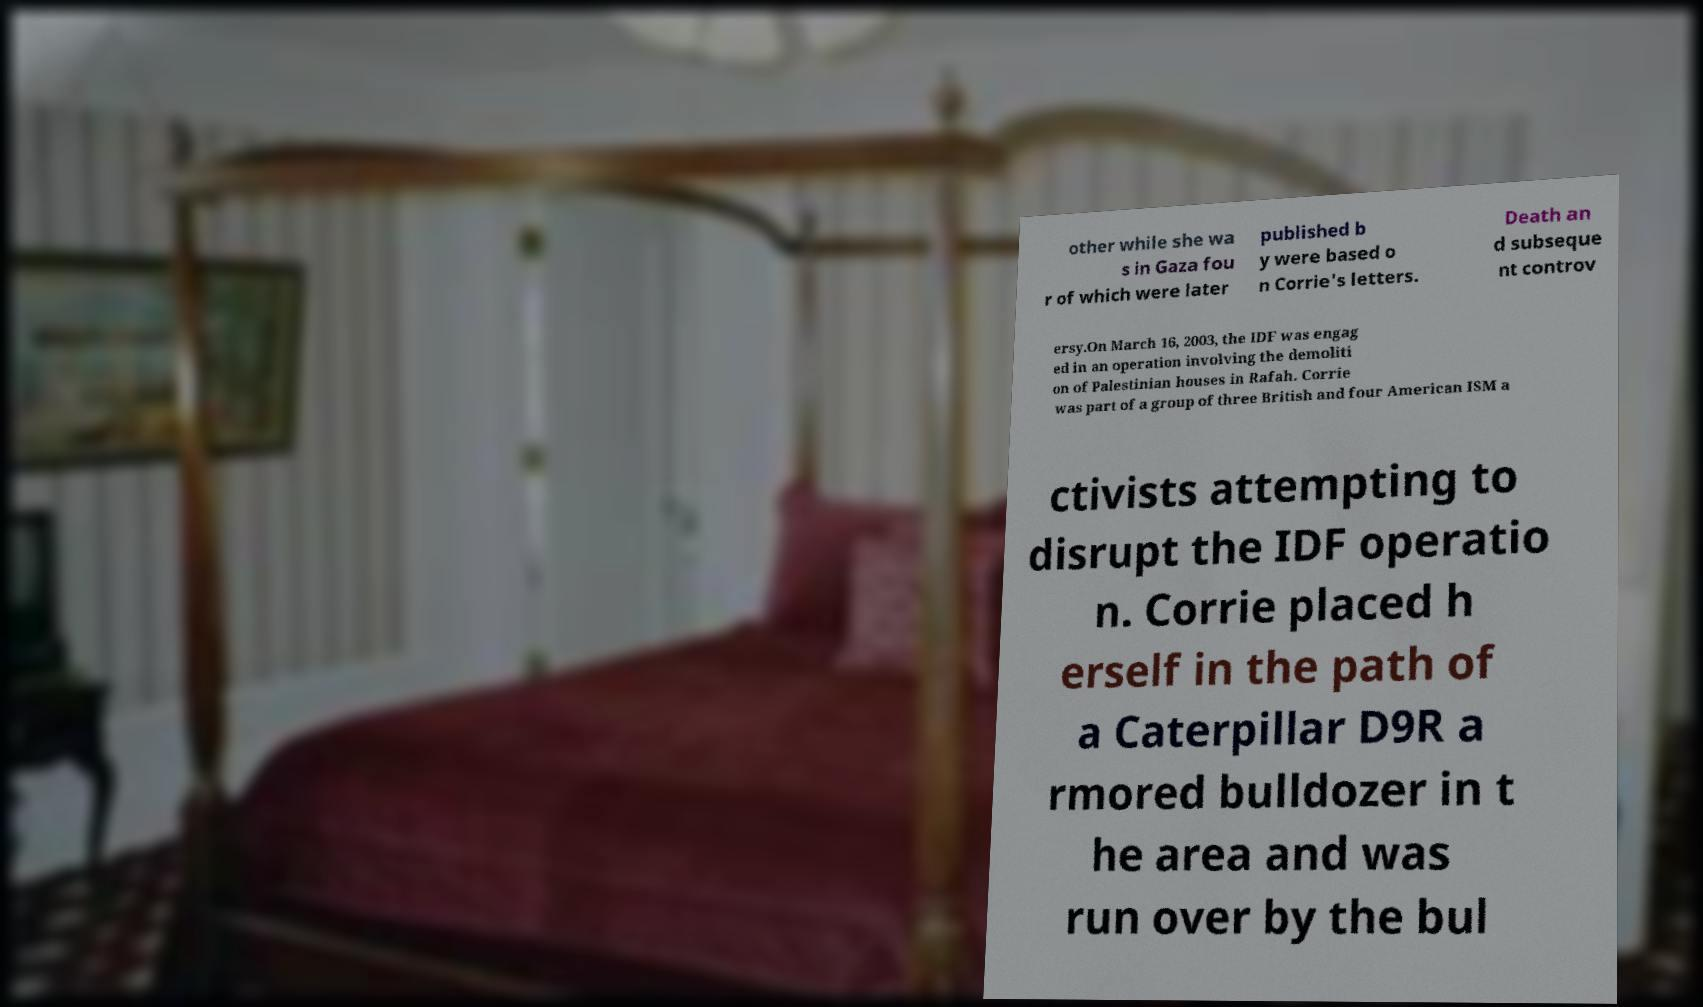For documentation purposes, I need the text within this image transcribed. Could you provide that? other while she wa s in Gaza fou r of which were later published b y were based o n Corrie's letters. Death an d subseque nt controv ersy.On March 16, 2003, the IDF was engag ed in an operation involving the demoliti on of Palestinian houses in Rafah. Corrie was part of a group of three British and four American ISM a ctivists attempting to disrupt the IDF operatio n. Corrie placed h erself in the path of a Caterpillar D9R a rmored bulldozer in t he area and was run over by the bul 